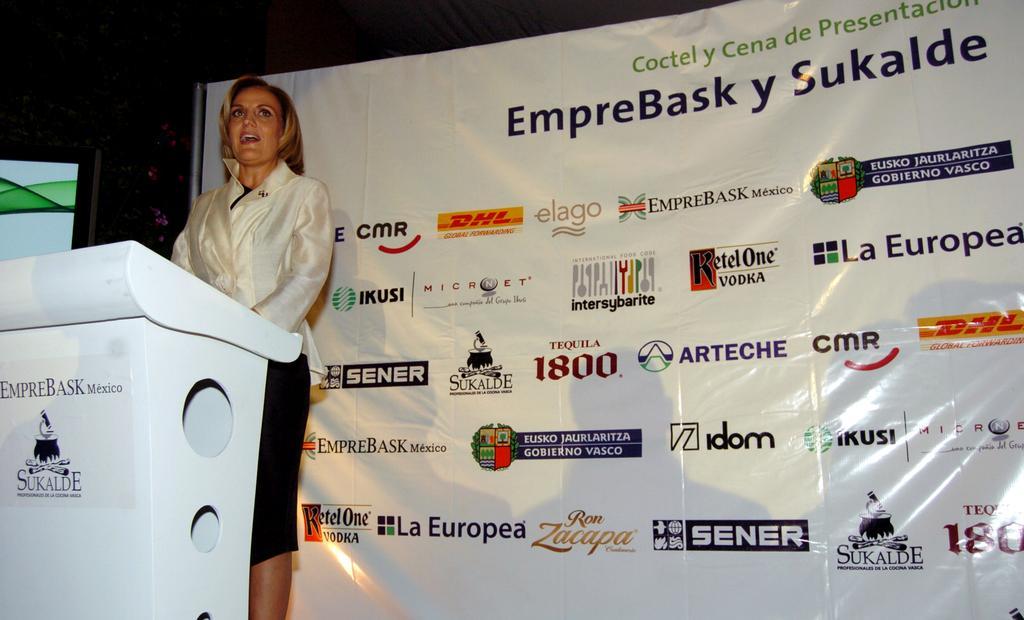How would you summarize this image in a sentence or two? In the image we can see a woman standing, wearing clothes and the woman is talking. In front of her there is a podium, white in color and behind her there is a banner. 